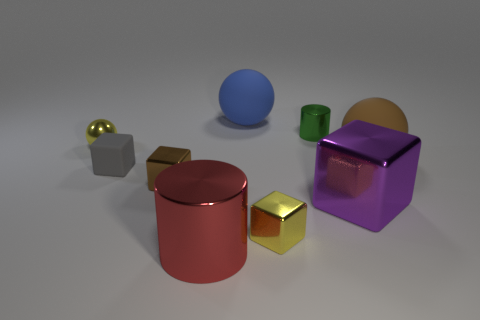Is the material of the tiny block on the right side of the red cylinder the same as the brown object on the right side of the tiny brown cube?
Your response must be concise. No. There is a yellow thing right of the tiny gray rubber cube; what shape is it?
Provide a short and direct response. Cube. Is the number of gray blocks less than the number of large yellow metal spheres?
Your response must be concise. No. There is a cylinder that is behind the tiny metallic object in front of the big purple shiny block; are there any gray objects in front of it?
Make the answer very short. Yes. What number of metal things are big brown objects or gray blocks?
Give a very brief answer. 0. Do the big metal cylinder and the small matte block have the same color?
Offer a terse response. No. How many green cylinders are right of the large cylinder?
Give a very brief answer. 1. How many spheres are to the left of the green metallic object and in front of the small green thing?
Offer a very short reply. 1. What shape is the big thing that is the same material as the red cylinder?
Provide a short and direct response. Cube. There is a yellow object in front of the big purple shiny thing; does it have the same size as the matte thing behind the green metallic cylinder?
Offer a terse response. No. 